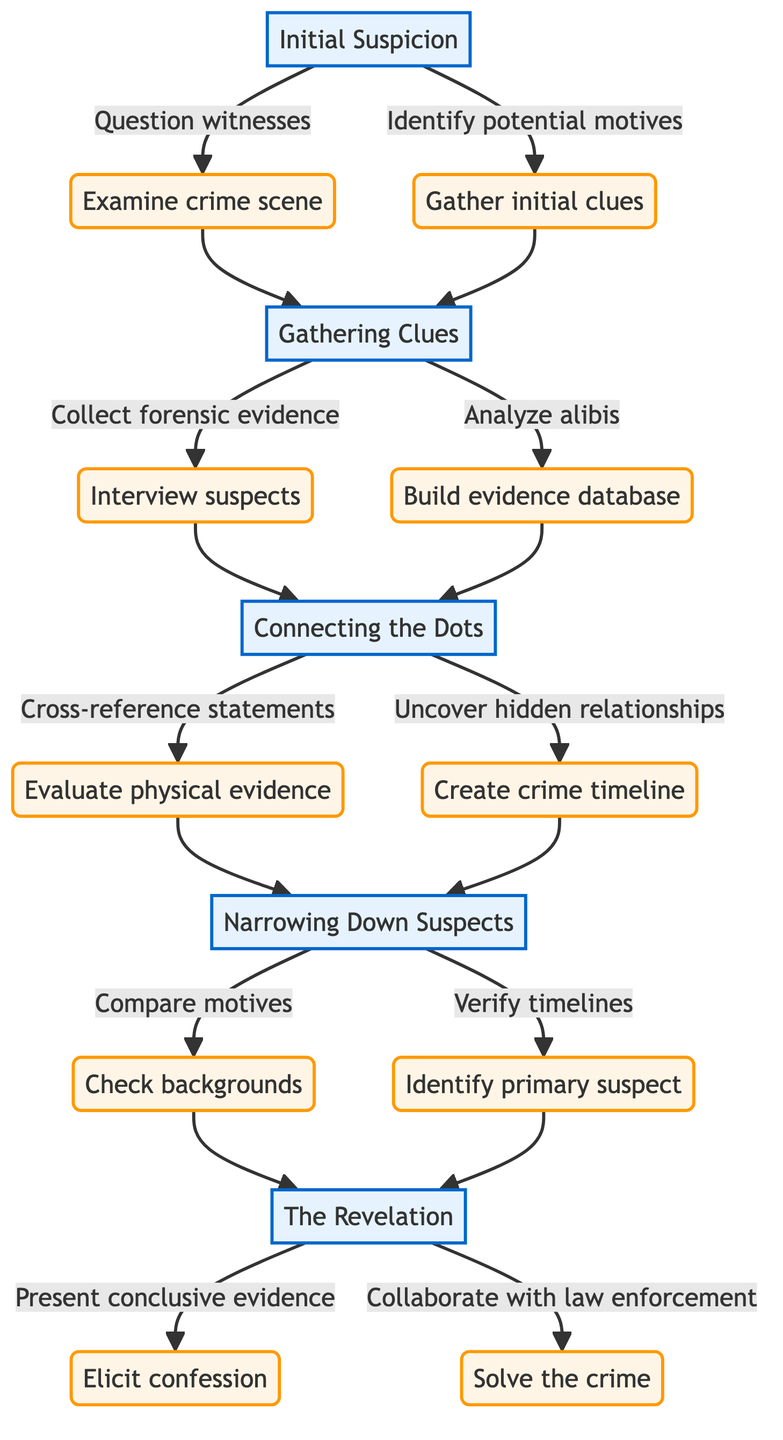What is the first stage in the Character's Journey? The first stage listed in the diagram is "Initial Suspicion". This is explicitly stated as the starting point of the character's journey.
Answer: Initial Suspicion How many key actions are associated with the "Gathering Clues" stage? In the "Gathering Clues" stage, there are three key actions listed: "Collect forensic evidence," "Interview suspects," and "Analyze alibis." Counting them gives a total of three actions.
Answer: 3 What stage follows "Connecting the Dots"? According to the flowchart, the stage that follows "Connecting the Dots" is "Narrowing Down Suspects", as indicated by the directional arrow leading to it.
Answer: Narrowing Down Suspects Which actions are taken in the "Narrowing Down Suspects" stage? In this stage, there are two actions: "Compare motives" and "Verify timelines". Both actions are connected to this stage in the diagram.
Answer: Compare motives, Verify timelines What is the final action in the "The Revelation" stage? The final action listed in the "The Revelation" stage involves "Collaborate with law enforcement." This completes the process depicted in the diagram.
Answer: Collaborate with law enforcement Which stages involve collecting evidence? The stages that involve collecting evidence include both "Gathering Clues" and "Connecting the Dots." The first stage collects evidence and the second involves analyzing it.
Answer: Gathering Clues, Connecting the Dots What is the relationship between "Initial Suspicion" and "Gathering Clues"? The relationship is that "Gathering Clues" is the next stage that follows "Initial Suspicion" after it is triggered by actions taken in that earlier stage, showcasing a sequential progression.
Answer: Sequential progression How many edges are in the diagram? To determine the number of edges, we count the direct connections between nodes. There are a total of 12 connections based on the directional arrows in the diagram, indicating the flow of the character's journey.
Answer: 12 Which action directly leads to "The Revelation"? The action that directly leads to "The Revelation" is "Check backgrounds", which is a part of the "Narrowing Down Suspects" stage. It is connected by the directional flow.
Answer: Check backgrounds 